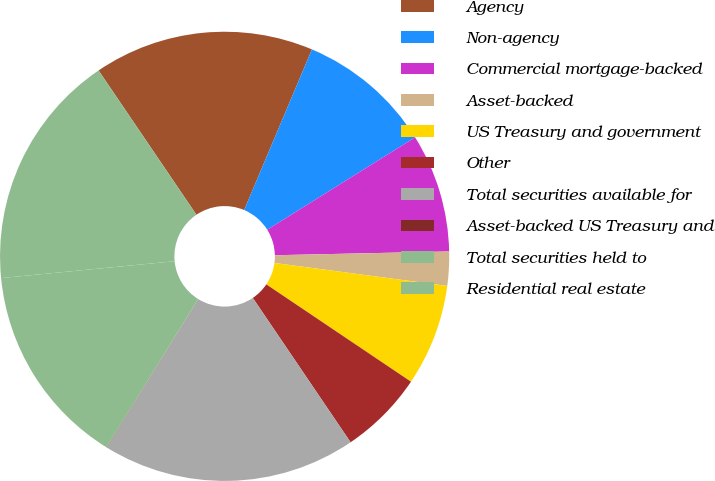Convert chart. <chart><loc_0><loc_0><loc_500><loc_500><pie_chart><fcel>Agency<fcel>Non-agency<fcel>Commercial mortgage-backed<fcel>Asset-backed<fcel>US Treasury and government<fcel>Other<fcel>Total securities available for<fcel>Asset-backed US Treasury and<fcel>Total securities held to<fcel>Residential real estate<nl><fcel>15.84%<fcel>9.76%<fcel>8.54%<fcel>2.45%<fcel>7.32%<fcel>6.1%<fcel>18.28%<fcel>0.02%<fcel>14.63%<fcel>17.06%<nl></chart> 